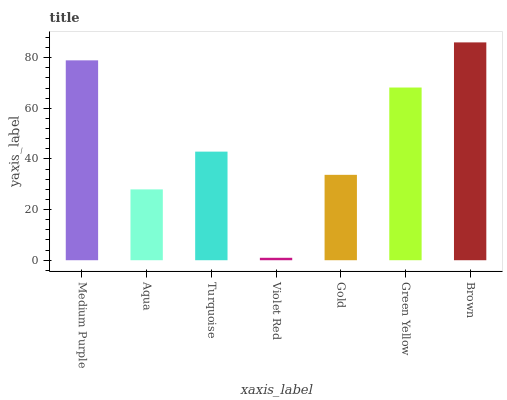Is Aqua the minimum?
Answer yes or no. No. Is Aqua the maximum?
Answer yes or no. No. Is Medium Purple greater than Aqua?
Answer yes or no. Yes. Is Aqua less than Medium Purple?
Answer yes or no. Yes. Is Aqua greater than Medium Purple?
Answer yes or no. No. Is Medium Purple less than Aqua?
Answer yes or no. No. Is Turquoise the high median?
Answer yes or no. Yes. Is Turquoise the low median?
Answer yes or no. Yes. Is Medium Purple the high median?
Answer yes or no. No. Is Brown the low median?
Answer yes or no. No. 